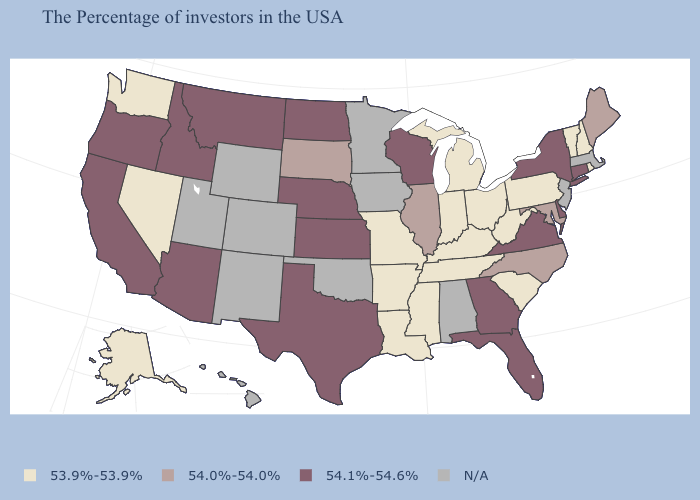Name the states that have a value in the range 54.1%-54.6%?
Short answer required. Connecticut, New York, Delaware, Virginia, Florida, Georgia, Wisconsin, Kansas, Nebraska, Texas, North Dakota, Montana, Arizona, Idaho, California, Oregon. Name the states that have a value in the range N/A?
Be succinct. Massachusetts, New Jersey, Alabama, Minnesota, Iowa, Oklahoma, Wyoming, Colorado, New Mexico, Utah, Hawaii. What is the value of West Virginia?
Concise answer only. 53.9%-53.9%. Does New York have the lowest value in the USA?
Be succinct. No. What is the highest value in states that border Mississippi?
Keep it brief. 53.9%-53.9%. Name the states that have a value in the range N/A?
Be succinct. Massachusetts, New Jersey, Alabama, Minnesota, Iowa, Oklahoma, Wyoming, Colorado, New Mexico, Utah, Hawaii. What is the value of Washington?
Be succinct. 53.9%-53.9%. Does the map have missing data?
Short answer required. Yes. Does Washington have the lowest value in the USA?
Quick response, please. Yes. What is the value of Wisconsin?
Concise answer only. 54.1%-54.6%. Name the states that have a value in the range 54.1%-54.6%?
Be succinct. Connecticut, New York, Delaware, Virginia, Florida, Georgia, Wisconsin, Kansas, Nebraska, Texas, North Dakota, Montana, Arizona, Idaho, California, Oregon. Name the states that have a value in the range N/A?
Concise answer only. Massachusetts, New Jersey, Alabama, Minnesota, Iowa, Oklahoma, Wyoming, Colorado, New Mexico, Utah, Hawaii. Does Arkansas have the highest value in the USA?
Be succinct. No. 